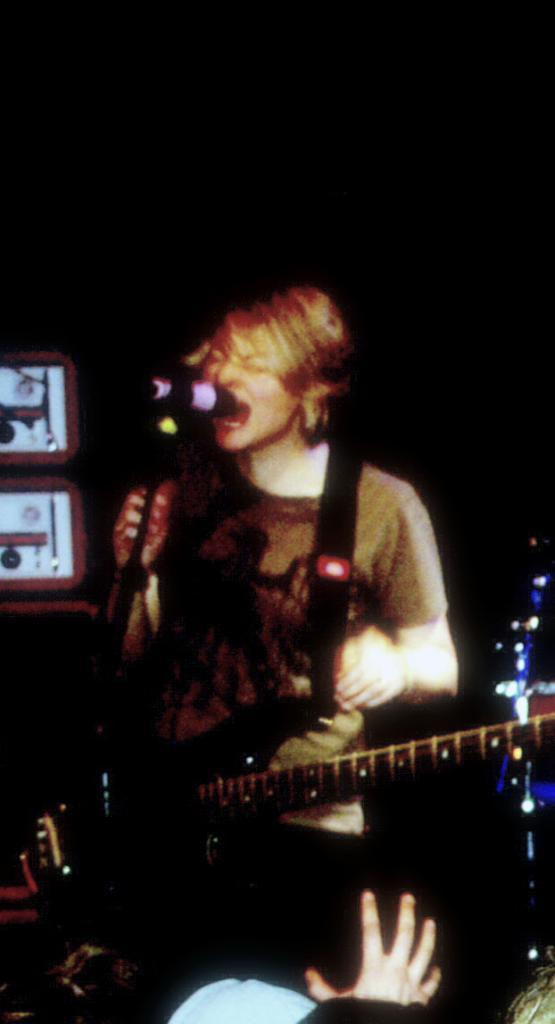What is the man in the image doing? The man is standing and singing in the image. What object is the man holding while singing? The man is holding a microphone. What can be seen in the background of the image? There is a window in the background of the image. What type of brass instrument is the man playing in the image? There is no brass instrument present in the image; the man is holding a microphone and singing. Can you see a bear in the image? No, there is no bear present in the image. 